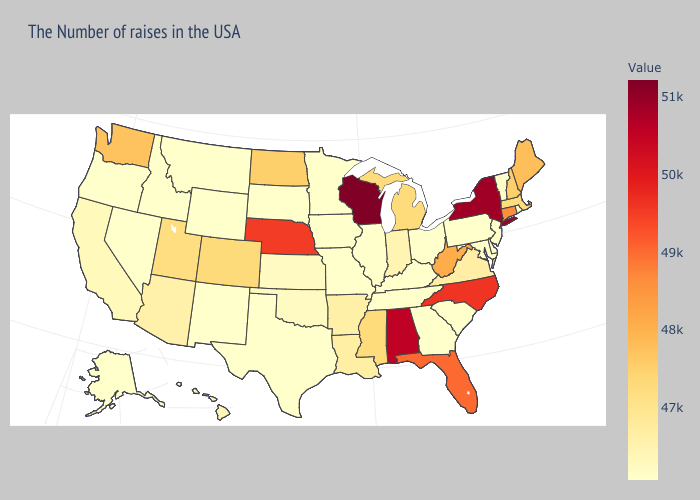Does Maryland have the lowest value in the South?
Answer briefly. Yes. Among the states that border Mississippi , which have the highest value?
Be succinct. Alabama. Which states hav the highest value in the MidWest?
Quick response, please. Wisconsin. 